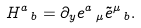Convert formula to latex. <formula><loc_0><loc_0><loc_500><loc_500>H ^ { a } \, _ { b } = \partial _ { y } e ^ { a } \, _ { \mu } \tilde { e } ^ { \mu } \, _ { b } .</formula> 